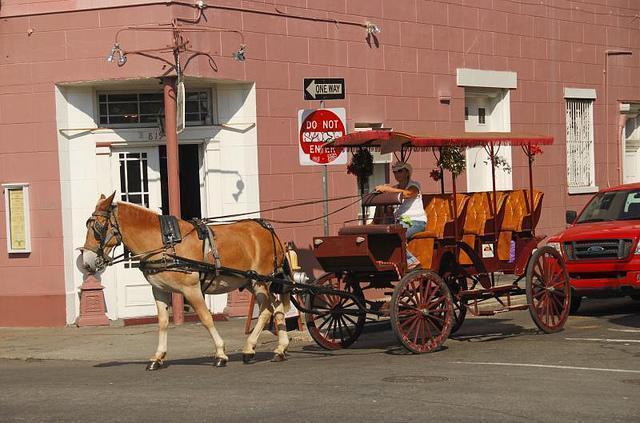What is the person in the carriage most likely looking for?
Choose the correct response, then elucidate: 'Answer: answer
Rationale: rationale.'
Options: Food, hay, predators, passengers. Answer: passengers.
Rationale: The horse needs food and water and that costs money. 